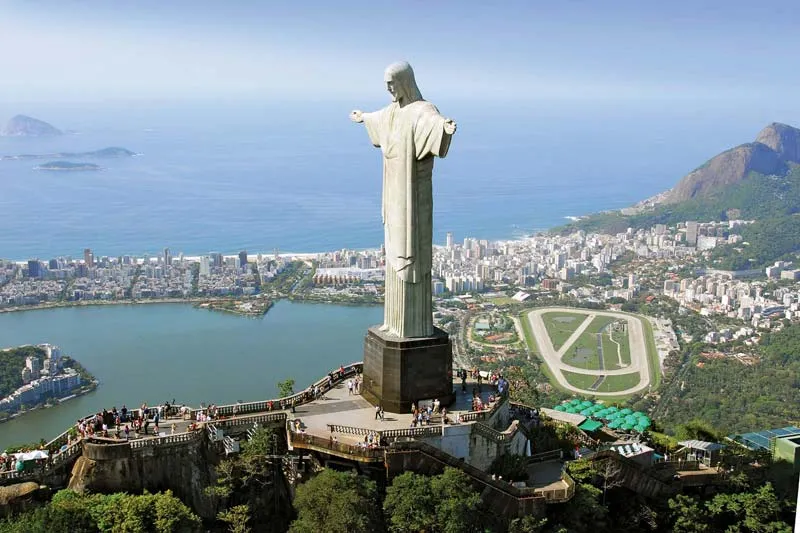If this image were turned into a painting, what artistic style would best capture its essence and why? An Impressionist style would best capture the essence of this image. The use of light and vibrant colors synonymous with Impressionism could beautifully convey the natural glow and dynamic energy of Rio de Janeiro. The soft, yet vivid brushstrokes would capture the serenity of the ocean, the rolling green hills, and the bustling city below. Emphasizing the play of natural light on the statue and the landscape would invoke a sense of warmth and grandeur, resonating with the peaceful and welcoming symbolism of Christ the Redeemer. 